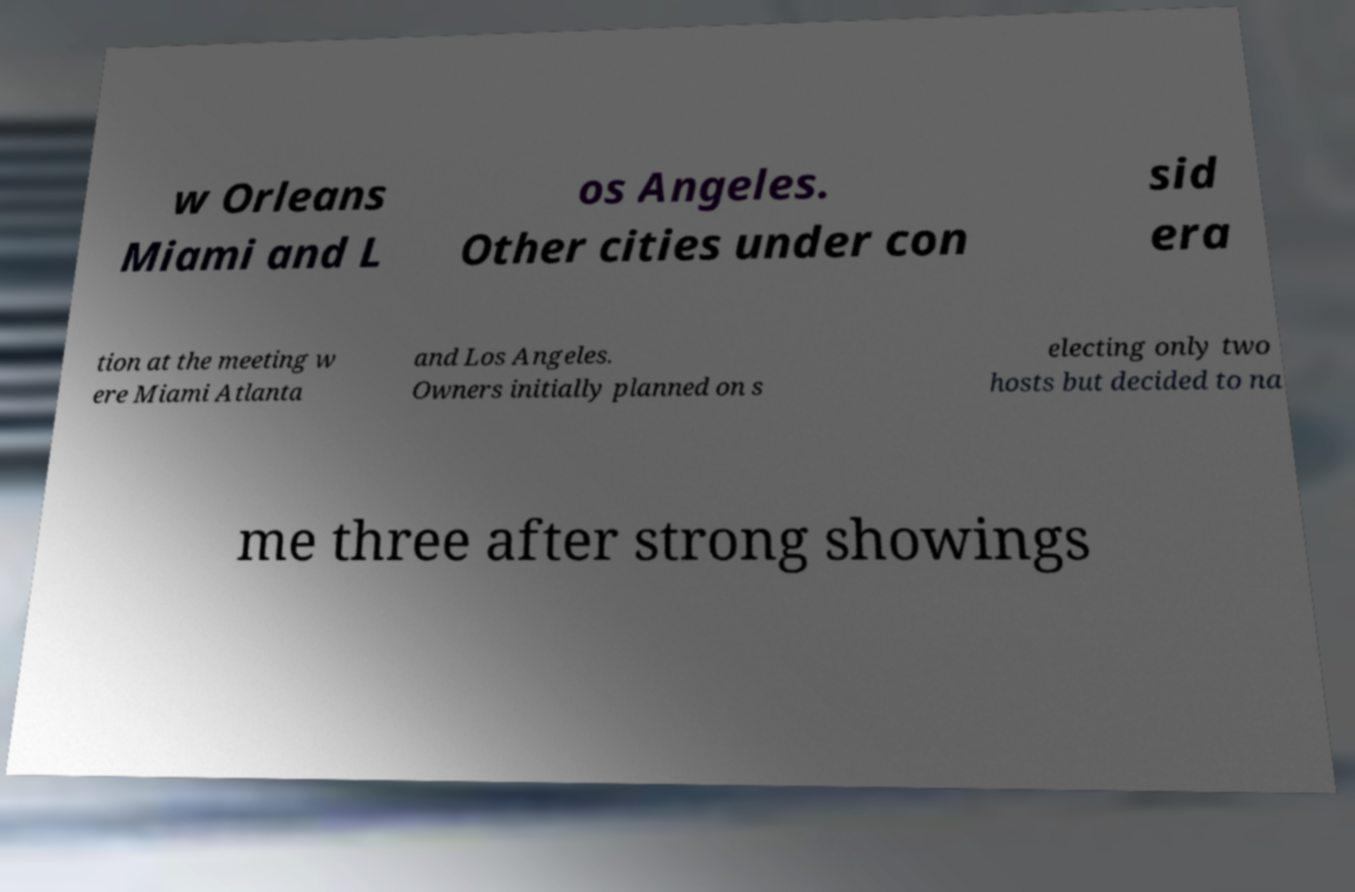For documentation purposes, I need the text within this image transcribed. Could you provide that? w Orleans Miami and L os Angeles. Other cities under con sid era tion at the meeting w ere Miami Atlanta and Los Angeles. Owners initially planned on s electing only two hosts but decided to na me three after strong showings 